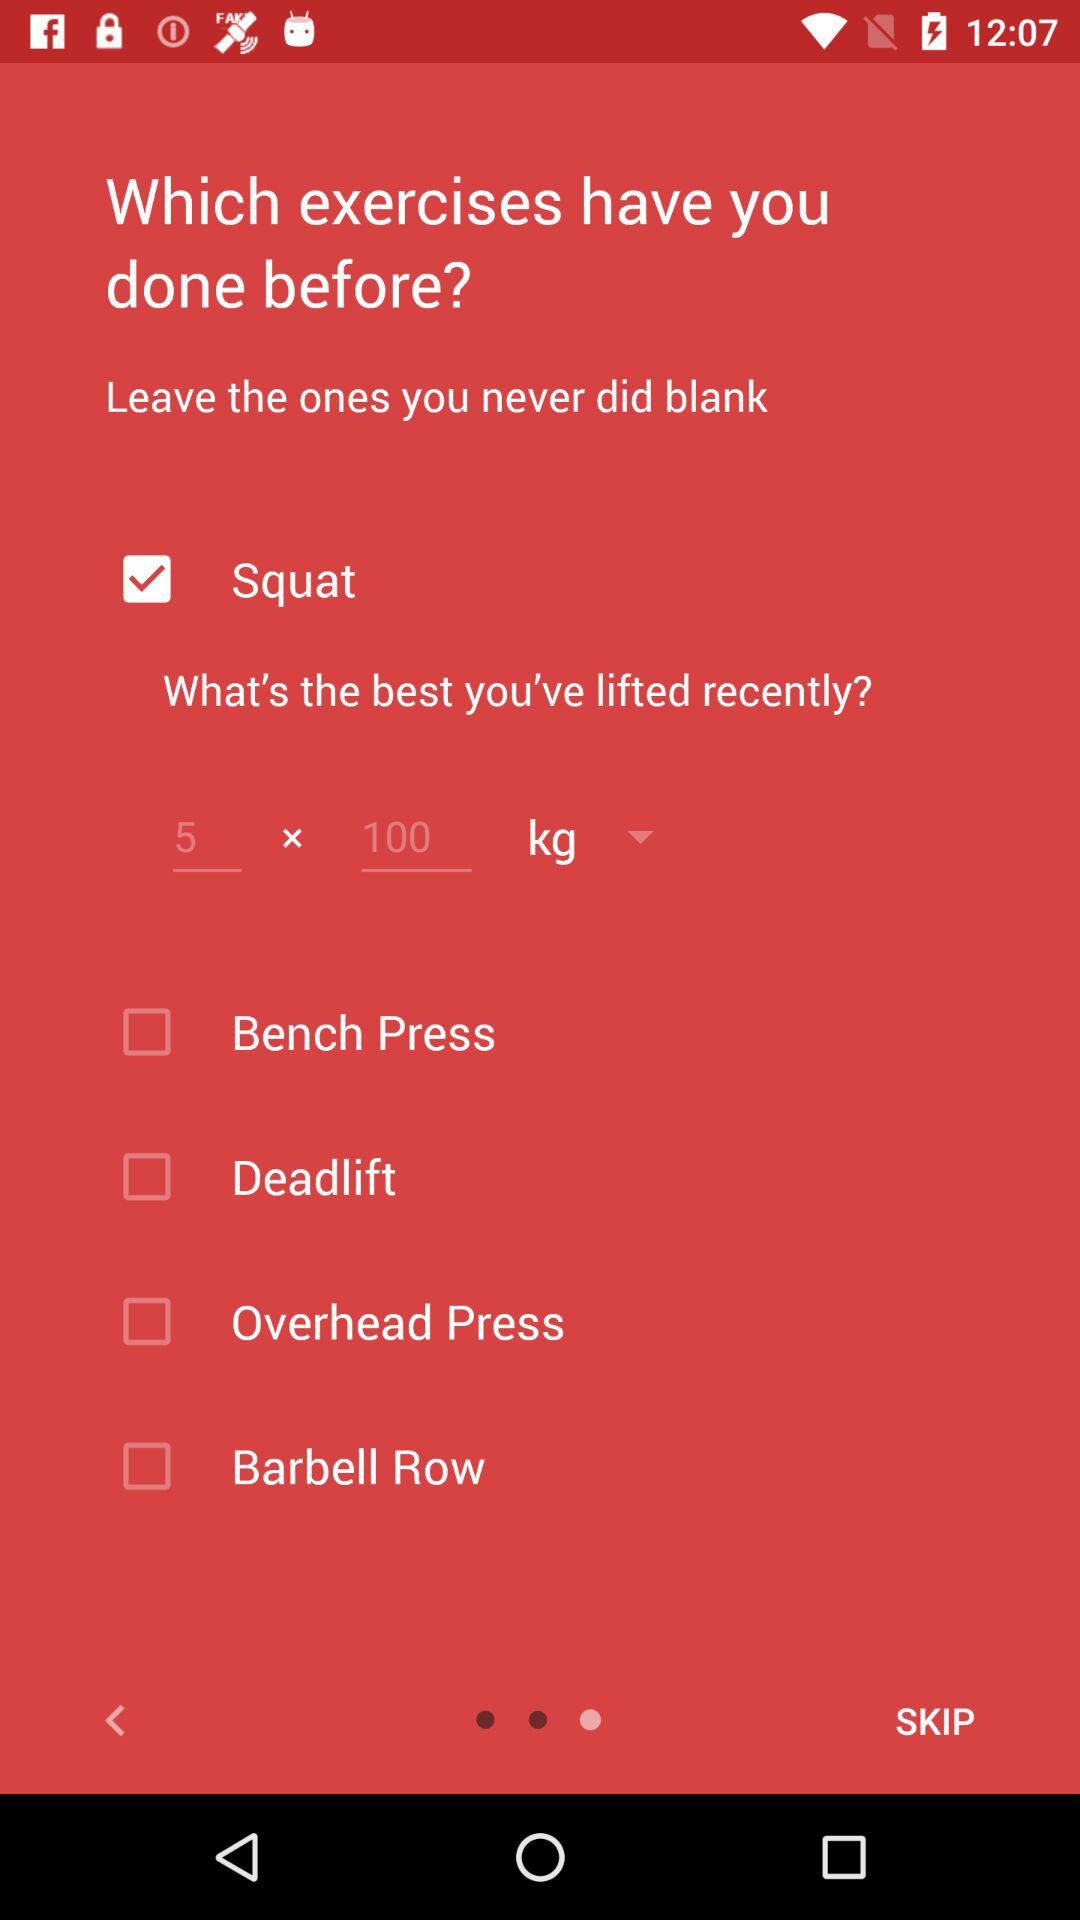How many exercises have the user already done?
Answer the question using a single word or phrase. 4 